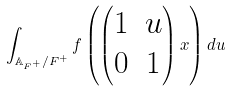Convert formula to latex. <formula><loc_0><loc_0><loc_500><loc_500>\int _ { \mathbb { A } _ { F ^ { + } } / F ^ { + } } f \left ( \begin{pmatrix} 1 & u \\ 0 & 1 \end{pmatrix} x \right ) d u</formula> 